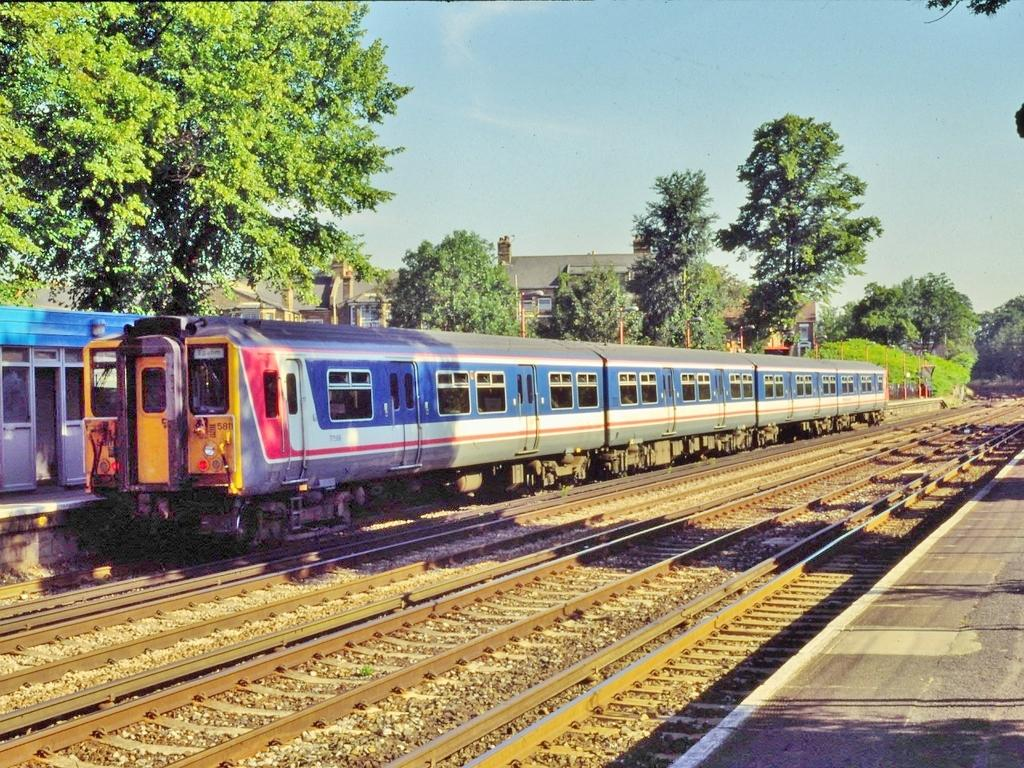What can be seen running along the ground in the image? There are railway tracks in the image. What is on the railway tracks? There is a blue color train on the railway tracks. What can be observed in relation to the objects in the image? Shadows are visible in the image. What type of natural elements are present in the image? There are trees in the image. What type of man-made structures are present in the image? There are buildings in the image. What is visible in the background of the image? The sky is visible in the image. How many boats are visible in the image? There are no boats present in the image. What type of paint is used to color the trees in the image? The image is a photograph, not a painting, so there is no paint used to color the trees. 